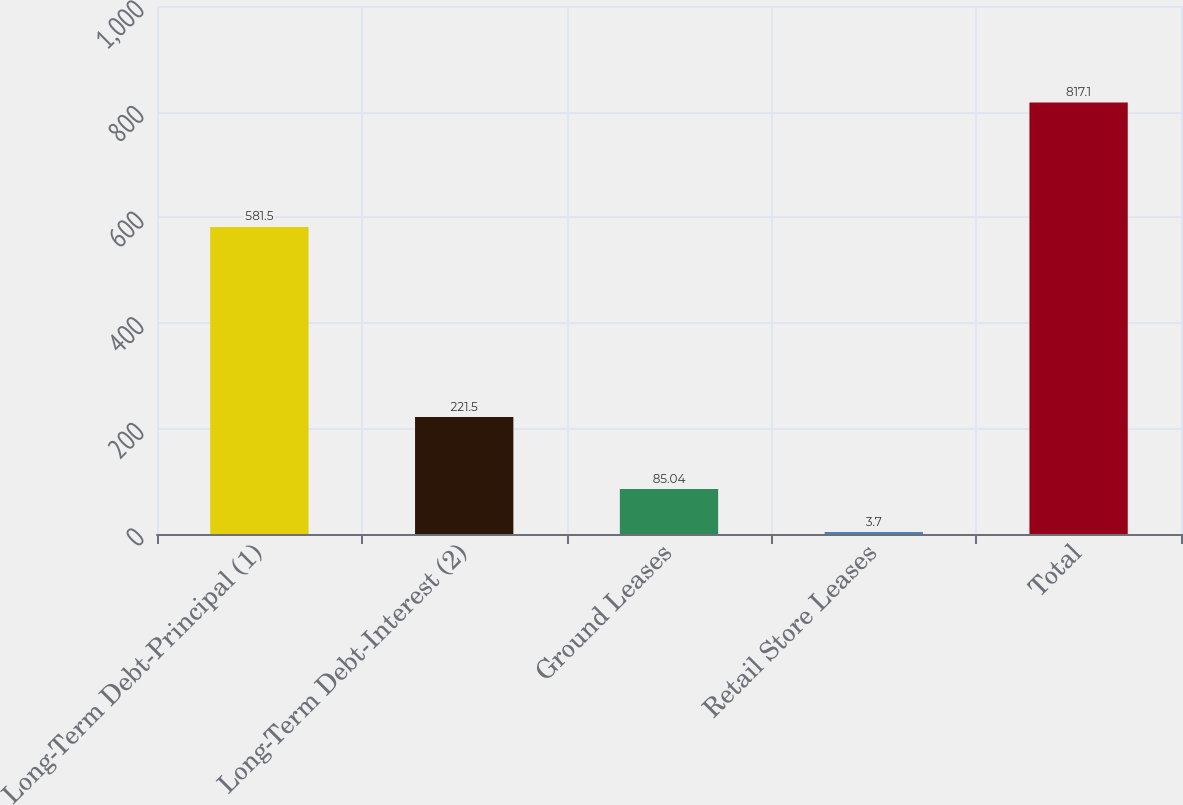Convert chart. <chart><loc_0><loc_0><loc_500><loc_500><bar_chart><fcel>Long-Term Debt-Principal (1)<fcel>Long-Term Debt-Interest (2)<fcel>Ground Leases<fcel>Retail Store Leases<fcel>Total<nl><fcel>581.5<fcel>221.5<fcel>85.04<fcel>3.7<fcel>817.1<nl></chart> 